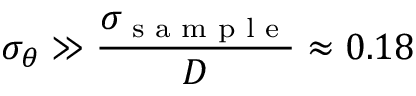<formula> <loc_0><loc_0><loc_500><loc_500>\sigma _ { \theta } \gg \frac { \sigma _ { s a m p l e } } { D } \approx 0 . 1 8</formula> 